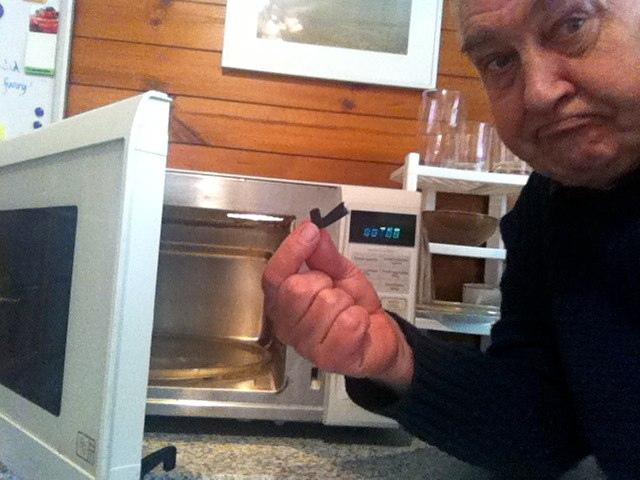What does the man hold?

Choices:
A) check mark
B) glasses
C) microwave part
D) dishes microwave part 